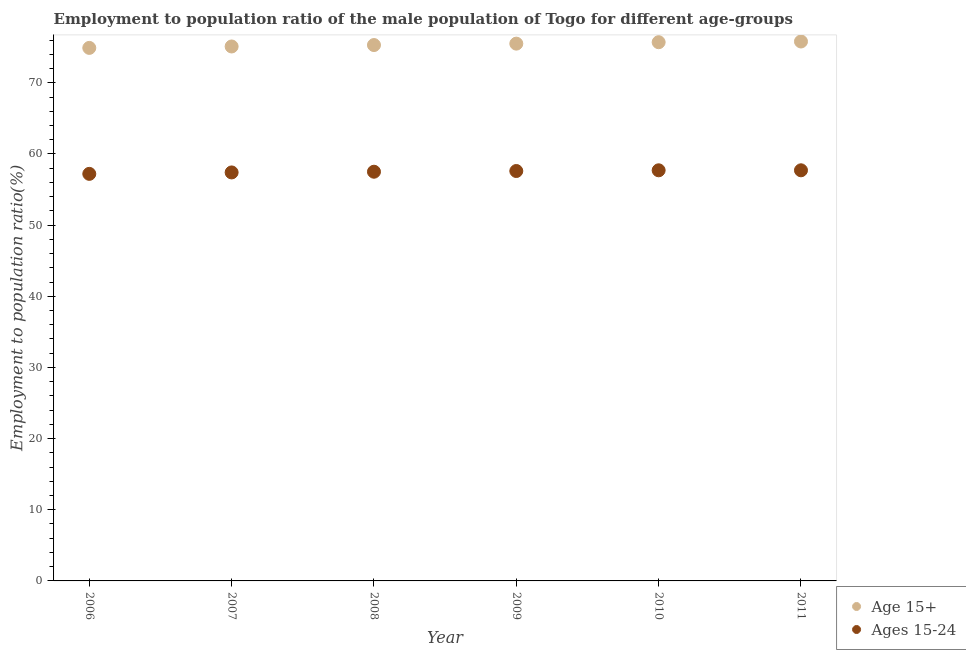How many different coloured dotlines are there?
Provide a succinct answer. 2. What is the employment to population ratio(age 15-24) in 2007?
Offer a terse response. 57.4. Across all years, what is the maximum employment to population ratio(age 15-24)?
Your response must be concise. 57.7. Across all years, what is the minimum employment to population ratio(age 15-24)?
Offer a terse response. 57.2. What is the total employment to population ratio(age 15-24) in the graph?
Ensure brevity in your answer.  345.1. What is the difference between the employment to population ratio(age 15-24) in 2006 and that in 2007?
Ensure brevity in your answer.  -0.2. What is the difference between the employment to population ratio(age 15+) in 2011 and the employment to population ratio(age 15-24) in 2007?
Provide a succinct answer. 18.4. What is the average employment to population ratio(age 15+) per year?
Your response must be concise. 75.38. In the year 2009, what is the difference between the employment to population ratio(age 15+) and employment to population ratio(age 15-24)?
Your answer should be very brief. 17.9. In how many years, is the employment to population ratio(age 15+) greater than 6 %?
Your answer should be compact. 6. What is the ratio of the employment to population ratio(age 15-24) in 2008 to that in 2010?
Your response must be concise. 1. What is the difference between the highest and the second highest employment to population ratio(age 15+)?
Offer a very short reply. 0.1. What is the difference between the highest and the lowest employment to population ratio(age 15+)?
Provide a short and direct response. 0.9. Does the employment to population ratio(age 15+) monotonically increase over the years?
Provide a succinct answer. Yes. Is the employment to population ratio(age 15+) strictly greater than the employment to population ratio(age 15-24) over the years?
Your response must be concise. Yes. Does the graph contain any zero values?
Your answer should be compact. No. Does the graph contain grids?
Offer a very short reply. No. How are the legend labels stacked?
Make the answer very short. Vertical. What is the title of the graph?
Your answer should be very brief. Employment to population ratio of the male population of Togo for different age-groups. What is the label or title of the X-axis?
Your answer should be compact. Year. What is the Employment to population ratio(%) of Age 15+ in 2006?
Your answer should be very brief. 74.9. What is the Employment to population ratio(%) in Ages 15-24 in 2006?
Ensure brevity in your answer.  57.2. What is the Employment to population ratio(%) of Age 15+ in 2007?
Offer a terse response. 75.1. What is the Employment to population ratio(%) of Ages 15-24 in 2007?
Provide a short and direct response. 57.4. What is the Employment to population ratio(%) in Age 15+ in 2008?
Your answer should be compact. 75.3. What is the Employment to population ratio(%) of Ages 15-24 in 2008?
Offer a very short reply. 57.5. What is the Employment to population ratio(%) in Age 15+ in 2009?
Your answer should be very brief. 75.5. What is the Employment to population ratio(%) of Ages 15-24 in 2009?
Give a very brief answer. 57.6. What is the Employment to population ratio(%) in Age 15+ in 2010?
Your response must be concise. 75.7. What is the Employment to population ratio(%) in Ages 15-24 in 2010?
Give a very brief answer. 57.7. What is the Employment to population ratio(%) in Age 15+ in 2011?
Make the answer very short. 75.8. What is the Employment to population ratio(%) in Ages 15-24 in 2011?
Provide a succinct answer. 57.7. Across all years, what is the maximum Employment to population ratio(%) of Age 15+?
Offer a terse response. 75.8. Across all years, what is the maximum Employment to population ratio(%) of Ages 15-24?
Make the answer very short. 57.7. Across all years, what is the minimum Employment to population ratio(%) in Age 15+?
Give a very brief answer. 74.9. Across all years, what is the minimum Employment to population ratio(%) in Ages 15-24?
Give a very brief answer. 57.2. What is the total Employment to population ratio(%) of Age 15+ in the graph?
Your response must be concise. 452.3. What is the total Employment to population ratio(%) in Ages 15-24 in the graph?
Make the answer very short. 345.1. What is the difference between the Employment to population ratio(%) in Ages 15-24 in 2006 and that in 2007?
Your answer should be compact. -0.2. What is the difference between the Employment to population ratio(%) in Ages 15-24 in 2006 and that in 2010?
Offer a very short reply. -0.5. What is the difference between the Employment to population ratio(%) of Age 15+ in 2007 and that in 2008?
Offer a very short reply. -0.2. What is the difference between the Employment to population ratio(%) in Ages 15-24 in 2007 and that in 2009?
Give a very brief answer. -0.2. What is the difference between the Employment to population ratio(%) of Ages 15-24 in 2007 and that in 2010?
Offer a terse response. -0.3. What is the difference between the Employment to population ratio(%) of Age 15+ in 2007 and that in 2011?
Give a very brief answer. -0.7. What is the difference between the Employment to population ratio(%) in Ages 15-24 in 2007 and that in 2011?
Your answer should be compact. -0.3. What is the difference between the Employment to population ratio(%) of Age 15+ in 2008 and that in 2009?
Provide a short and direct response. -0.2. What is the difference between the Employment to population ratio(%) in Ages 15-24 in 2008 and that in 2009?
Give a very brief answer. -0.1. What is the difference between the Employment to population ratio(%) of Age 15+ in 2008 and that in 2011?
Keep it short and to the point. -0.5. What is the difference between the Employment to population ratio(%) of Age 15+ in 2009 and that in 2010?
Ensure brevity in your answer.  -0.2. What is the difference between the Employment to population ratio(%) of Ages 15-24 in 2009 and that in 2010?
Your answer should be compact. -0.1. What is the difference between the Employment to population ratio(%) in Age 15+ in 2009 and that in 2011?
Offer a very short reply. -0.3. What is the difference between the Employment to population ratio(%) of Age 15+ in 2010 and that in 2011?
Your answer should be compact. -0.1. What is the difference between the Employment to population ratio(%) in Age 15+ in 2006 and the Employment to population ratio(%) in Ages 15-24 in 2010?
Make the answer very short. 17.2. What is the difference between the Employment to population ratio(%) of Age 15+ in 2007 and the Employment to population ratio(%) of Ages 15-24 in 2010?
Make the answer very short. 17.4. What is the difference between the Employment to population ratio(%) in Age 15+ in 2007 and the Employment to population ratio(%) in Ages 15-24 in 2011?
Offer a terse response. 17.4. What is the difference between the Employment to population ratio(%) of Age 15+ in 2008 and the Employment to population ratio(%) of Ages 15-24 in 2009?
Give a very brief answer. 17.7. What is the difference between the Employment to population ratio(%) of Age 15+ in 2008 and the Employment to population ratio(%) of Ages 15-24 in 2010?
Your response must be concise. 17.6. What is the difference between the Employment to population ratio(%) in Age 15+ in 2008 and the Employment to population ratio(%) in Ages 15-24 in 2011?
Offer a very short reply. 17.6. What is the difference between the Employment to population ratio(%) in Age 15+ in 2009 and the Employment to population ratio(%) in Ages 15-24 in 2011?
Your response must be concise. 17.8. What is the average Employment to population ratio(%) in Age 15+ per year?
Provide a short and direct response. 75.38. What is the average Employment to population ratio(%) of Ages 15-24 per year?
Keep it short and to the point. 57.52. In the year 2008, what is the difference between the Employment to population ratio(%) of Age 15+ and Employment to population ratio(%) of Ages 15-24?
Your answer should be compact. 17.8. What is the ratio of the Employment to population ratio(%) in Ages 15-24 in 2006 to that in 2009?
Make the answer very short. 0.99. What is the ratio of the Employment to population ratio(%) in Age 15+ in 2006 to that in 2010?
Your response must be concise. 0.99. What is the ratio of the Employment to population ratio(%) of Age 15+ in 2006 to that in 2011?
Offer a very short reply. 0.99. What is the ratio of the Employment to population ratio(%) of Ages 15-24 in 2006 to that in 2011?
Make the answer very short. 0.99. What is the ratio of the Employment to population ratio(%) of Age 15+ in 2007 to that in 2009?
Ensure brevity in your answer.  0.99. What is the ratio of the Employment to population ratio(%) of Ages 15-24 in 2007 to that in 2009?
Ensure brevity in your answer.  1. What is the ratio of the Employment to population ratio(%) in Age 15+ in 2007 to that in 2011?
Give a very brief answer. 0.99. What is the ratio of the Employment to population ratio(%) of Ages 15-24 in 2007 to that in 2011?
Make the answer very short. 0.99. What is the ratio of the Employment to population ratio(%) of Age 15+ in 2008 to that in 2009?
Keep it short and to the point. 1. What is the ratio of the Employment to population ratio(%) in Age 15+ in 2008 to that in 2011?
Give a very brief answer. 0.99. What is the ratio of the Employment to population ratio(%) in Ages 15-24 in 2009 to that in 2010?
Make the answer very short. 1. What is the ratio of the Employment to population ratio(%) of Age 15+ in 2009 to that in 2011?
Your response must be concise. 1. What is the ratio of the Employment to population ratio(%) of Ages 15-24 in 2010 to that in 2011?
Offer a very short reply. 1. What is the difference between the highest and the second highest Employment to population ratio(%) of Age 15+?
Your response must be concise. 0.1. 